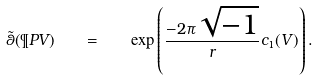Convert formula to latex. <formula><loc_0><loc_0><loc_500><loc_500>\tilde { \theta } ( \P P { V } ) \quad = \quad \exp \left ( \frac { - 2 \pi \sqrt { - 1 } } { r } c _ { 1 } ( V ) \right ) .</formula> 